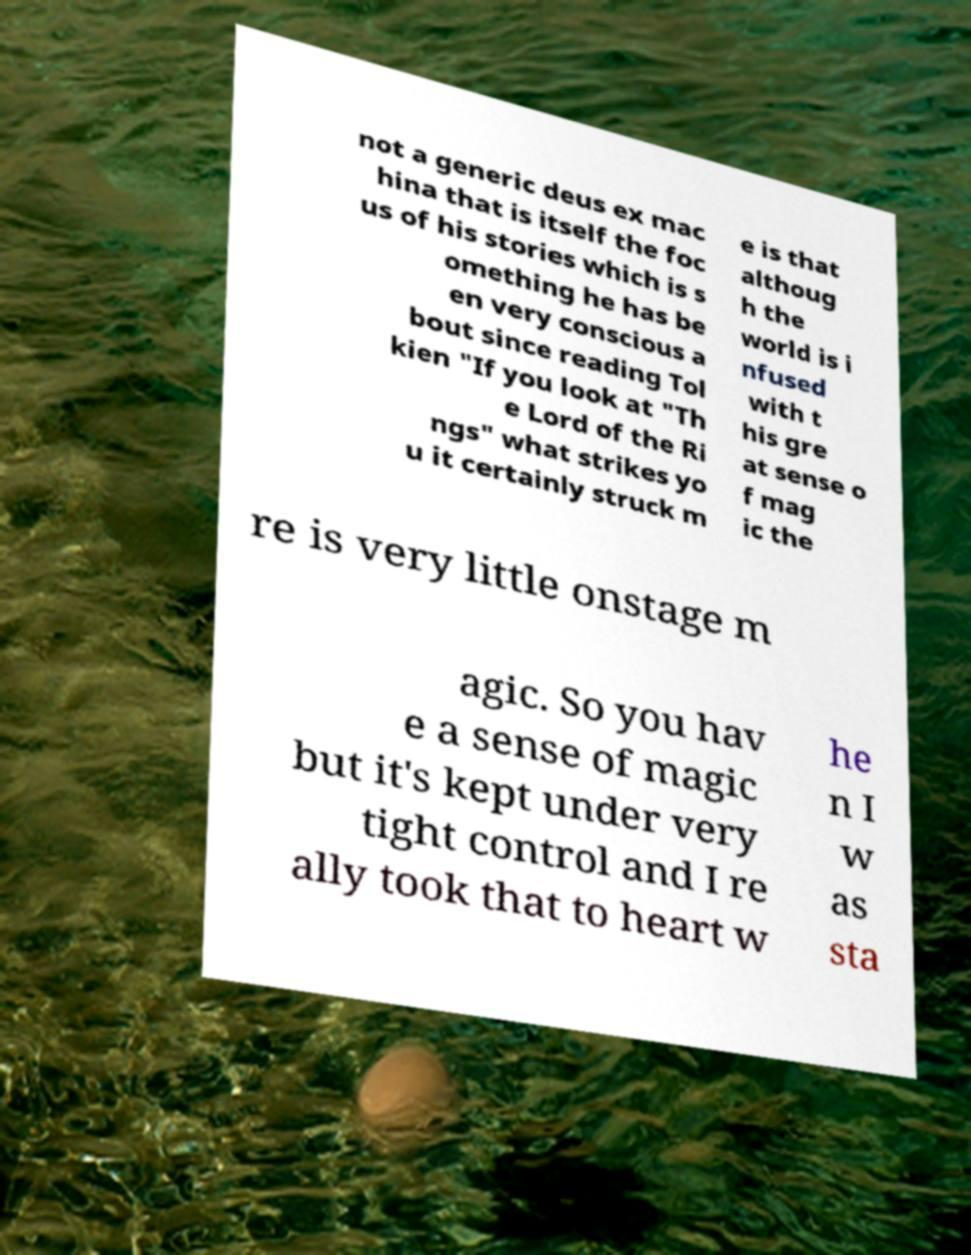Please read and relay the text visible in this image. What does it say? not a generic deus ex mac hina that is itself the foc us of his stories which is s omething he has be en very conscious a bout since reading Tol kien "If you look at "Th e Lord of the Ri ngs" what strikes yo u it certainly struck m e is that althoug h the world is i nfused with t his gre at sense o f mag ic the re is very little onstage m agic. So you hav e a sense of magic but it's kept under very tight control and I re ally took that to heart w he n I w as sta 